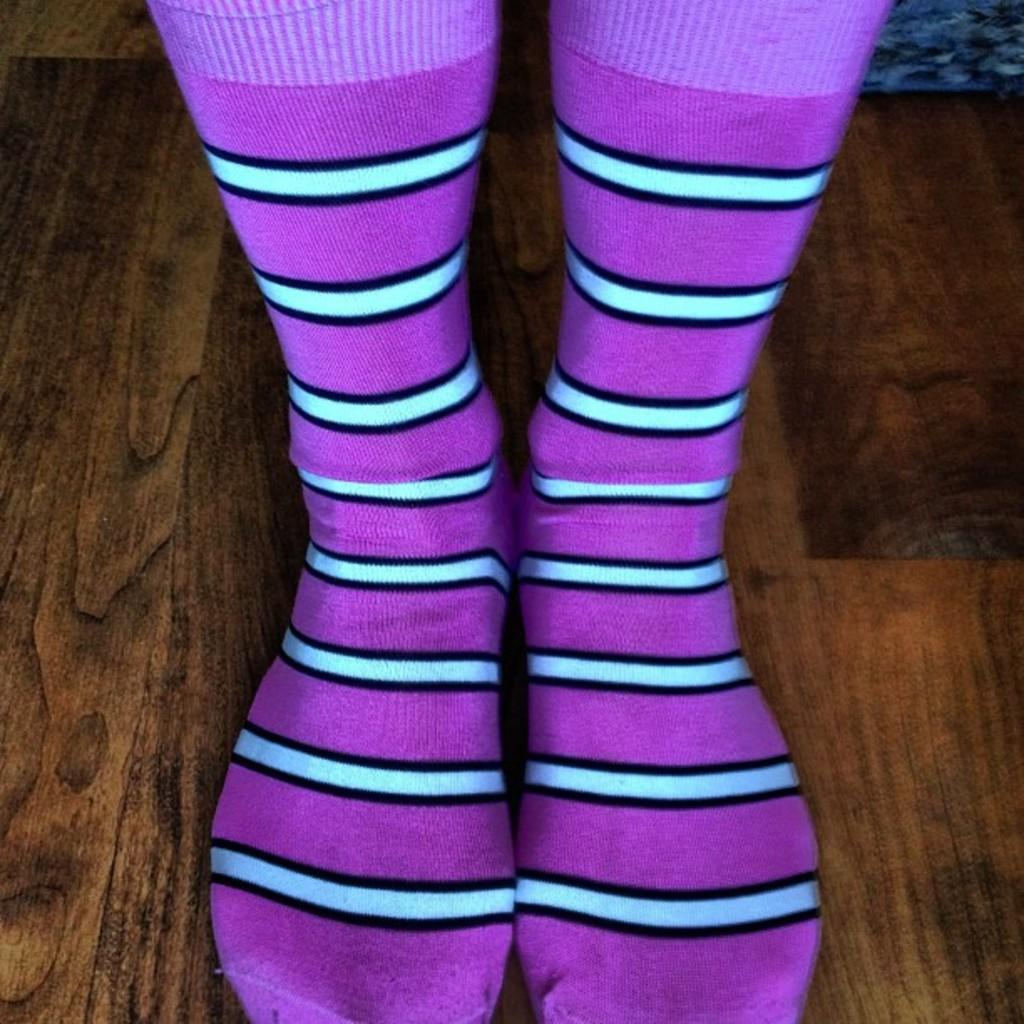What type of clothing item is in the image? There is a pair of socks in the image. What colors are the socks? The socks are purple and blue in color. Where are the socks located in the image? The socks are on a wooden floor. How many centimeters long is the airport in the image? There is no airport present in the image, so it is not possible to determine its length in centimeters. 